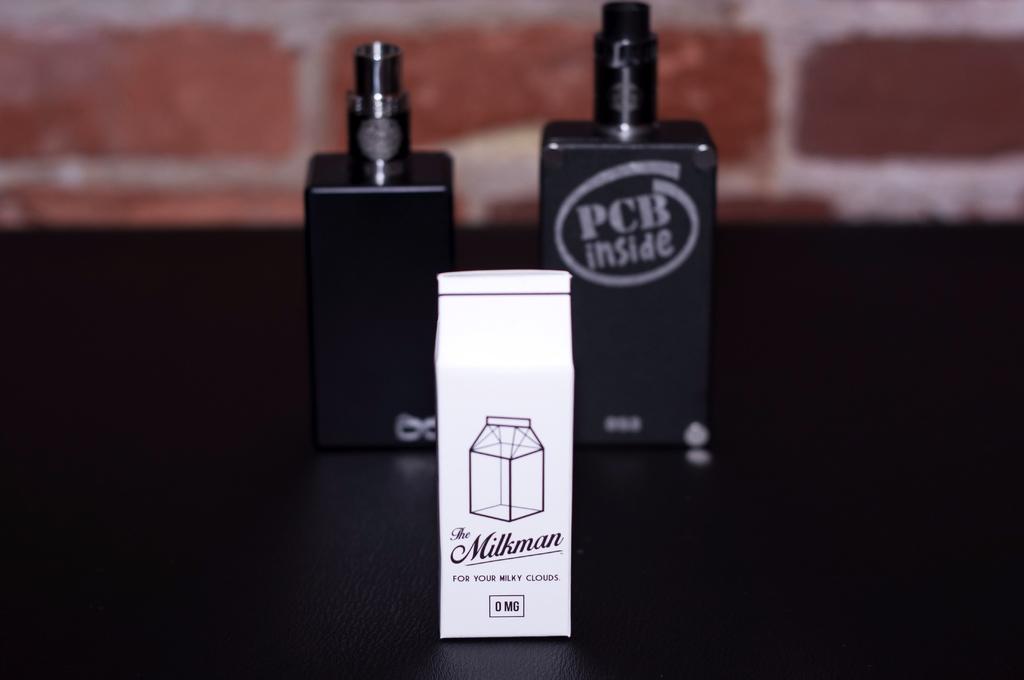What is inside the larger black container?
Provide a short and direct response. Pcb. What is the brand on the white bag?
Your answer should be very brief. The milkman. 